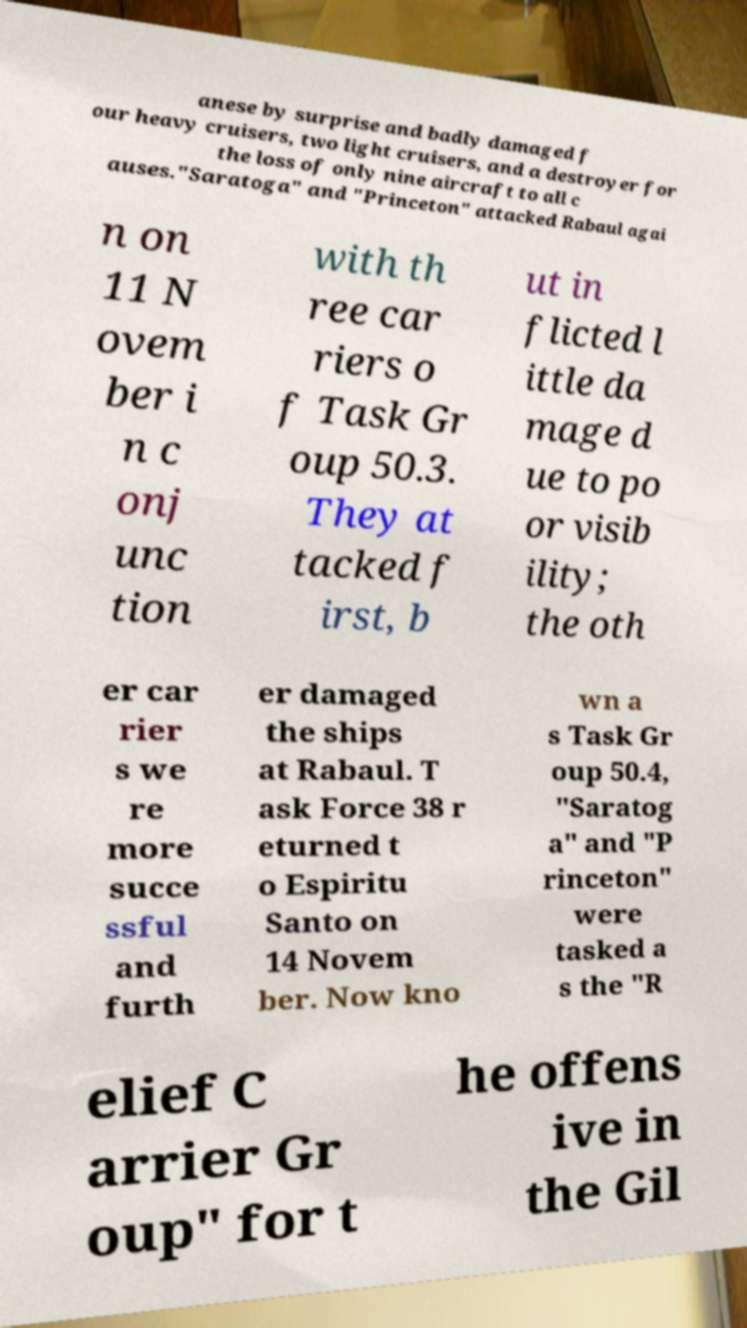Can you accurately transcribe the text from the provided image for me? anese by surprise and badly damaged f our heavy cruisers, two light cruisers, and a destroyer for the loss of only nine aircraft to all c auses."Saratoga" and "Princeton" attacked Rabaul agai n on 11 N ovem ber i n c onj unc tion with th ree car riers o f Task Gr oup 50.3. They at tacked f irst, b ut in flicted l ittle da mage d ue to po or visib ility; the oth er car rier s we re more succe ssful and furth er damaged the ships at Rabaul. T ask Force 38 r eturned t o Espiritu Santo on 14 Novem ber. Now kno wn a s Task Gr oup 50.4, "Saratog a" and "P rinceton" were tasked a s the "R elief C arrier Gr oup" for t he offens ive in the Gil 